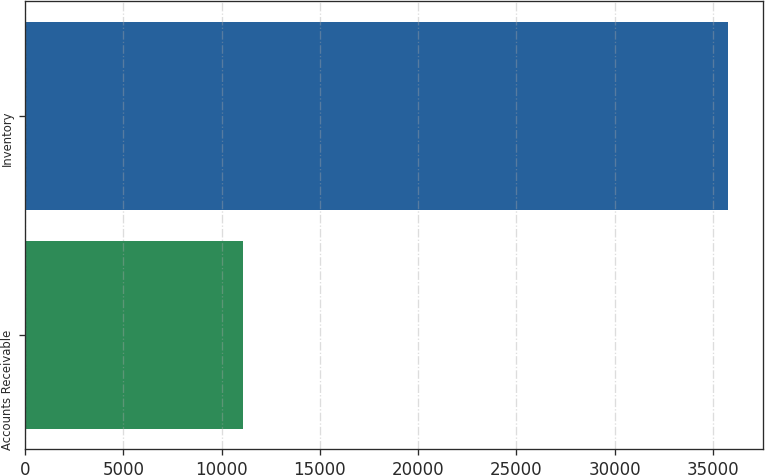Convert chart to OTSL. <chart><loc_0><loc_0><loc_500><loc_500><bar_chart><fcel>Accounts Receivable<fcel>Inventory<nl><fcel>11082<fcel>35759<nl></chart> 